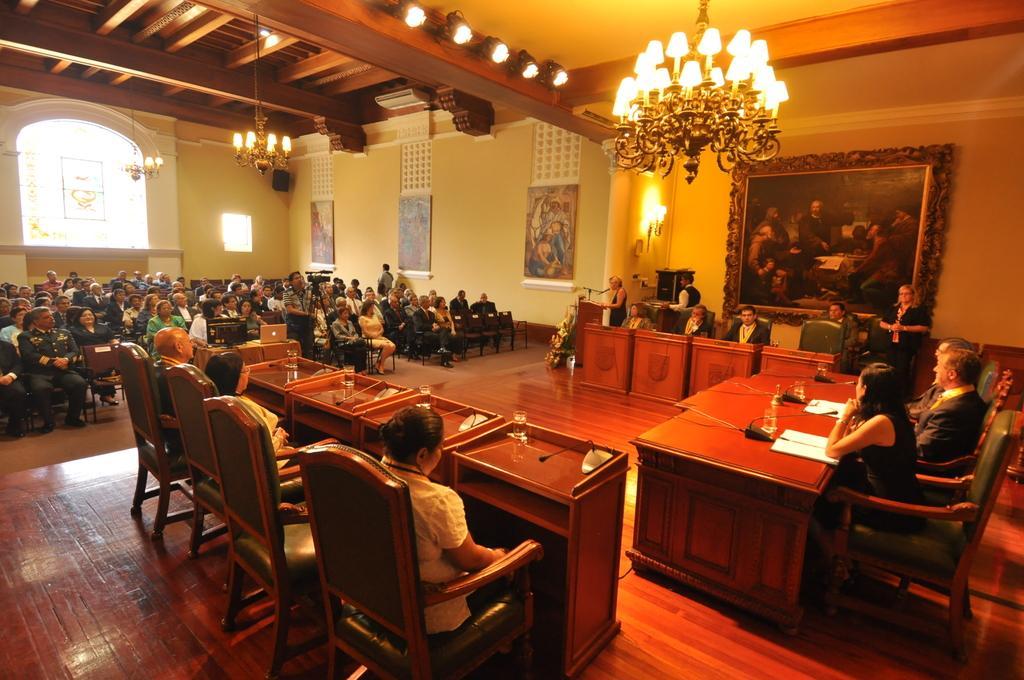Could you give a brief overview of what you see in this image? In this image i can see group of people sitting on a chair there is a podium and a micro phone in front of the person,at the back ground there is a frame attached to a wall,at the top there is a chandelier. 